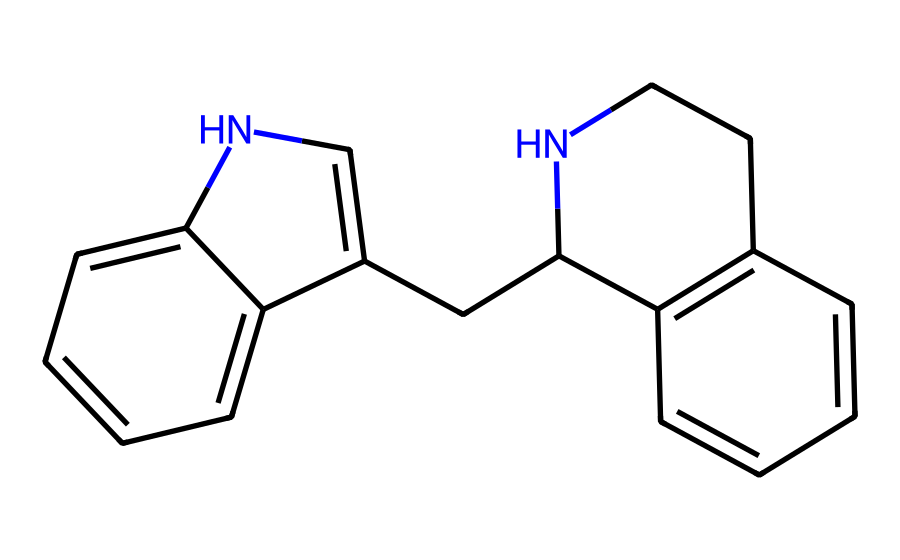What is the total number of nitrogen atoms in this compound? By examining the SMILES representation, we can identify the presence of nitrogen atoms. In the structure, there are two distinct nitrogen atoms present, indicated by the 'N' in the SMILES.
Answer: 2 How many aromatic rings are present in this chemical structure? In the provided SMILES, we can observe multiple cycles within the structure. Specifically, there are two fused aromatic rings, indicated by the alternating double bonds in the cyclic structures.
Answer: 2 What type of functional groups can be observed in this structure? By interpreting the structure's SMILES, we identify the presence of nitrogen atoms and their positions in the rings, suggesting that it belongs to the class of indole alkaloids, which are characterized by nitrogen-containing aromatic compounds.
Answer: alkaloid Which element has the highest atomic count in this compound? Analyzing the constituent atoms from the SMILES, we account for carbon and nitrogen. The number of carbon atoms is greater than that of nitrogen, specifically, there are 14 carbon atoms in comparison to just 2 nitrogen atoms. Thus, carbon has the highest count.
Answer: carbon What is the aromaticity characteristic in the rings of this compound? The structure reveals that it contains conjugated pi systems due to alternating double bonds in the cyclic parts, which meet the criteria for aromaticity (huckel's rule). Thus, these rings are considered aromatic.
Answer: aromatic 